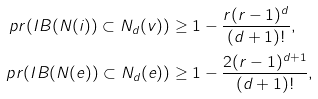<formula> <loc_0><loc_0><loc_500><loc_500>\ p r ( I B ( N ( i ) ) \subset N _ { d } ( v ) ) & \geq 1 - \frac { r ( r - 1 ) ^ { d } } { ( d + 1 ) ! } , \\ \ p r ( I B ( N ( e ) ) \subset N _ { d } ( e ) ) & \geq 1 - \frac { 2 ( r - 1 ) ^ { d + 1 } } { ( d + 1 ) ! } ,</formula> 